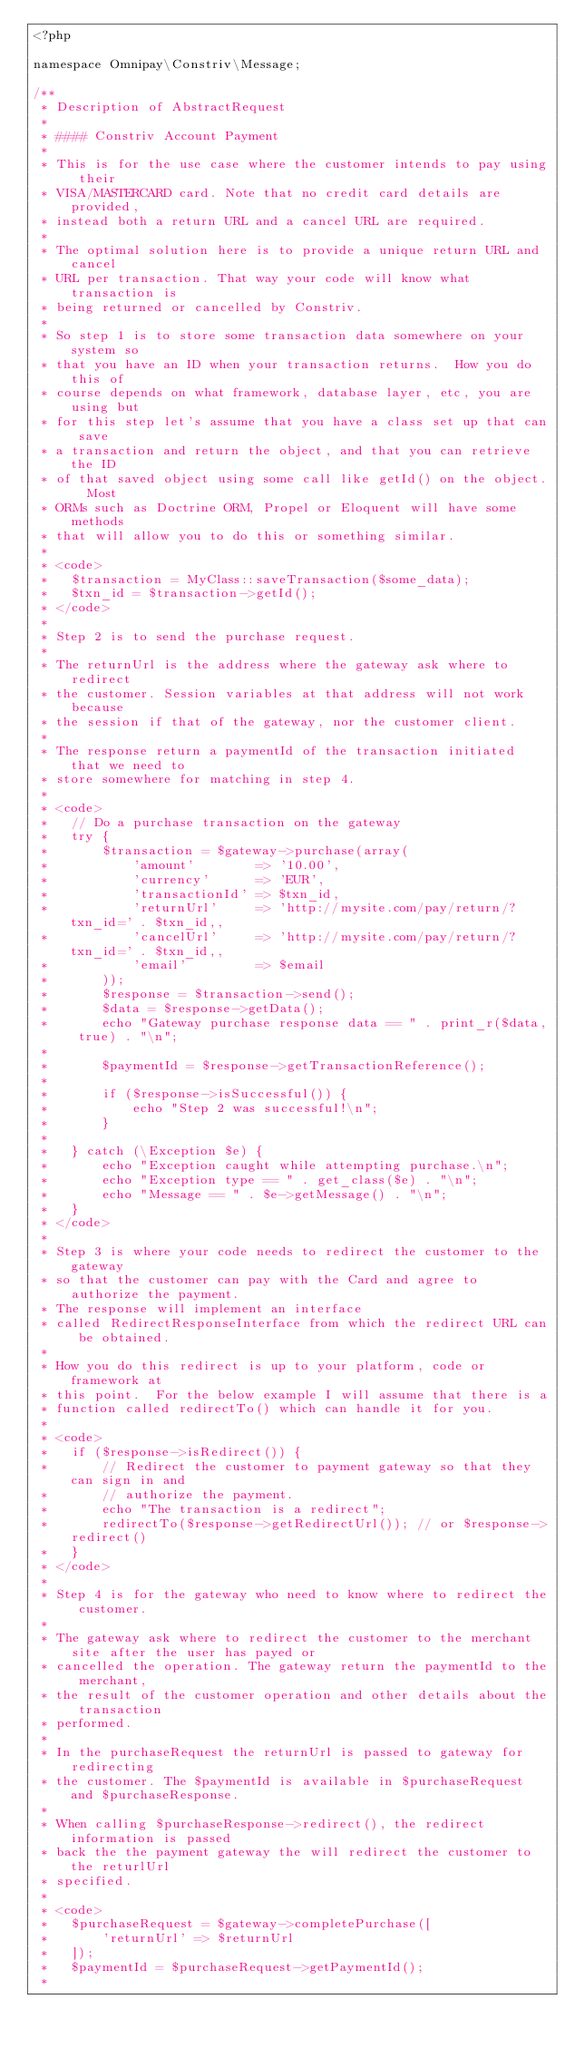Convert code to text. <code><loc_0><loc_0><loc_500><loc_500><_PHP_><?php

namespace Omnipay\Constriv\Message;

/**
 * Description of AbstractRequest
 * 
 * #### Constriv Account Payment
 *
 * This is for the use case where the customer intends to pay using their
 * VISA/MASTERCARD card. Note that no credit card details are provided, 
 * instead both a return URL and a cancel URL are required.
 *
 * The optimal solution here is to provide a unique return URL and cancel
 * URL per transaction. That way your code will know what transaction is
 * being returned or cancelled by Constriv.
 *
 * So step 1 is to store some transaction data somewhere on your system so
 * that you have an ID when your transaction returns.  How you do this of
 * course depends on what framework, database layer, etc, you are using but
 * for this step let's assume that you have a class set up that can save
 * a transaction and return the object, and that you can retrieve the ID
 * of that saved object using some call like getId() on the object.  Most
 * ORMs such as Doctrine ORM, Propel or Eloquent will have some methods
 * that will allow you to do this or something similar.
 *
 * <code>
 *   $transaction = MyClass::saveTransaction($some_data);
 *   $txn_id = $transaction->getId();
 * </code>
 *
 * Step 2 is to send the purchase request.
 * 
 * The returnUrl is the address where the gateway ask where to redirect
 * the customer. Session variables at that address will not work because 
 * the session if that of the gateway, nor the customer client.
 * 
 * The response return a paymentId of the transaction initiated that we need to 
 * store somewhere for matching in step 4.
 * 
 * <code>
 *   // Do a purchase transaction on the gateway
 *   try {
 *       $transaction = $gateway->purchase(array(
 *           'amount'        => '10.00',
 *           'currency'      => 'EUR',
 *           'transactionId' => $txn_id,
 *           'returnUrl'     => 'http://mysite.com/pay/return/?txn_id=' . $txn_id,,
 *           'cancelUrl'     => 'http://mysite.com/pay/return/?txn_id=' . $txn_id,,
 *           'email'         => $email 
 *       ));
 *       $response = $transaction->send();
 *       $data = $response->getData();
 *       echo "Gateway purchase response data == " . print_r($data, true) . "\n";
 *
 *       $paymentId = $response->getTransactionReference();
 * 
 *       if ($response->isSuccessful()) {
 *           echo "Step 2 was successful!\n";
 *       }
 *
 *   } catch (\Exception $e) {
 *       echo "Exception caught while attempting purchase.\n";
 *       echo "Exception type == " . get_class($e) . "\n";
 *       echo "Message == " . $e->getMessage() . "\n";
 *   }
 * </code>
 *
 * Step 3 is where your code needs to redirect the customer to the gateway 
 * so that the customer can pay with the Card and agree to authorize the payment.
 * The response will implement an interface
 * called RedirectResponseInterface from which the redirect URL can be obtained.
 *
 * How you do this redirect is up to your platform, code or framework at
 * this point.  For the below example I will assume that there is a
 * function called redirectTo() which can handle it for you.
 *
 * <code>
 *   if ($response->isRedirect()) {
 *       // Redirect the customer to payment gateway so that they can sign in and
 *       // authorize the payment.
 *       echo "The transaction is a redirect";
 *       redirectTo($response->getRedirectUrl()); // or $response->redirect()
 *   }
 * </code>
 * 
 * Step 4 is for the gateway who need to know where to redirect the customer.
 * 
 * The gateway ask where to redirect the customer to the merchant site after the user has payed or
 * cancelled the operation. The gateway return the paymentId to the merchant,
 * the result of the customer operation and other details about the transaction
 * performed.
 * 
 * In the purchaseRequest the returnUrl is passed to gateway for redirecting
 * the customer. The $paymentId is available in $purchaseRequest and $purchaseResponse.
 * 
 * When calling $purchaseResponse->redirect(), the redirect information is passed 
 * back the the payment gateway the will redirect the customer to the returlUrl
 * specified.
 * 
 * <code>
 *   $purchaseRequest = $gateway->completePurchase([
 *       'returnUrl' => $returnUrl
 *   ]);
 *   $paymentId = $purchaseRequest->getPaymentId();
 * </code> 